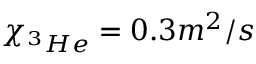<formula> <loc_0><loc_0><loc_500><loc_500>\chi _ { ^ { 3 } H e } = 0 . 3 m ^ { 2 } / s</formula> 